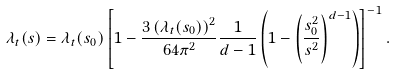<formula> <loc_0><loc_0><loc_500><loc_500>\lambda _ { t } ( s ) = \lambda _ { t } ( s _ { 0 } ) \left [ 1 - \frac { 3 \left ( \lambda _ { t } ( s _ { 0 } ) \right ) ^ { 2 } } { 6 4 \pi ^ { 2 } } \frac { 1 } { d - 1 } \left ( 1 - \left ( \frac { s _ { 0 } ^ { 2 } } { s ^ { 2 } } \right ) ^ { d - 1 } \right ) \right ] ^ { - 1 } .</formula> 